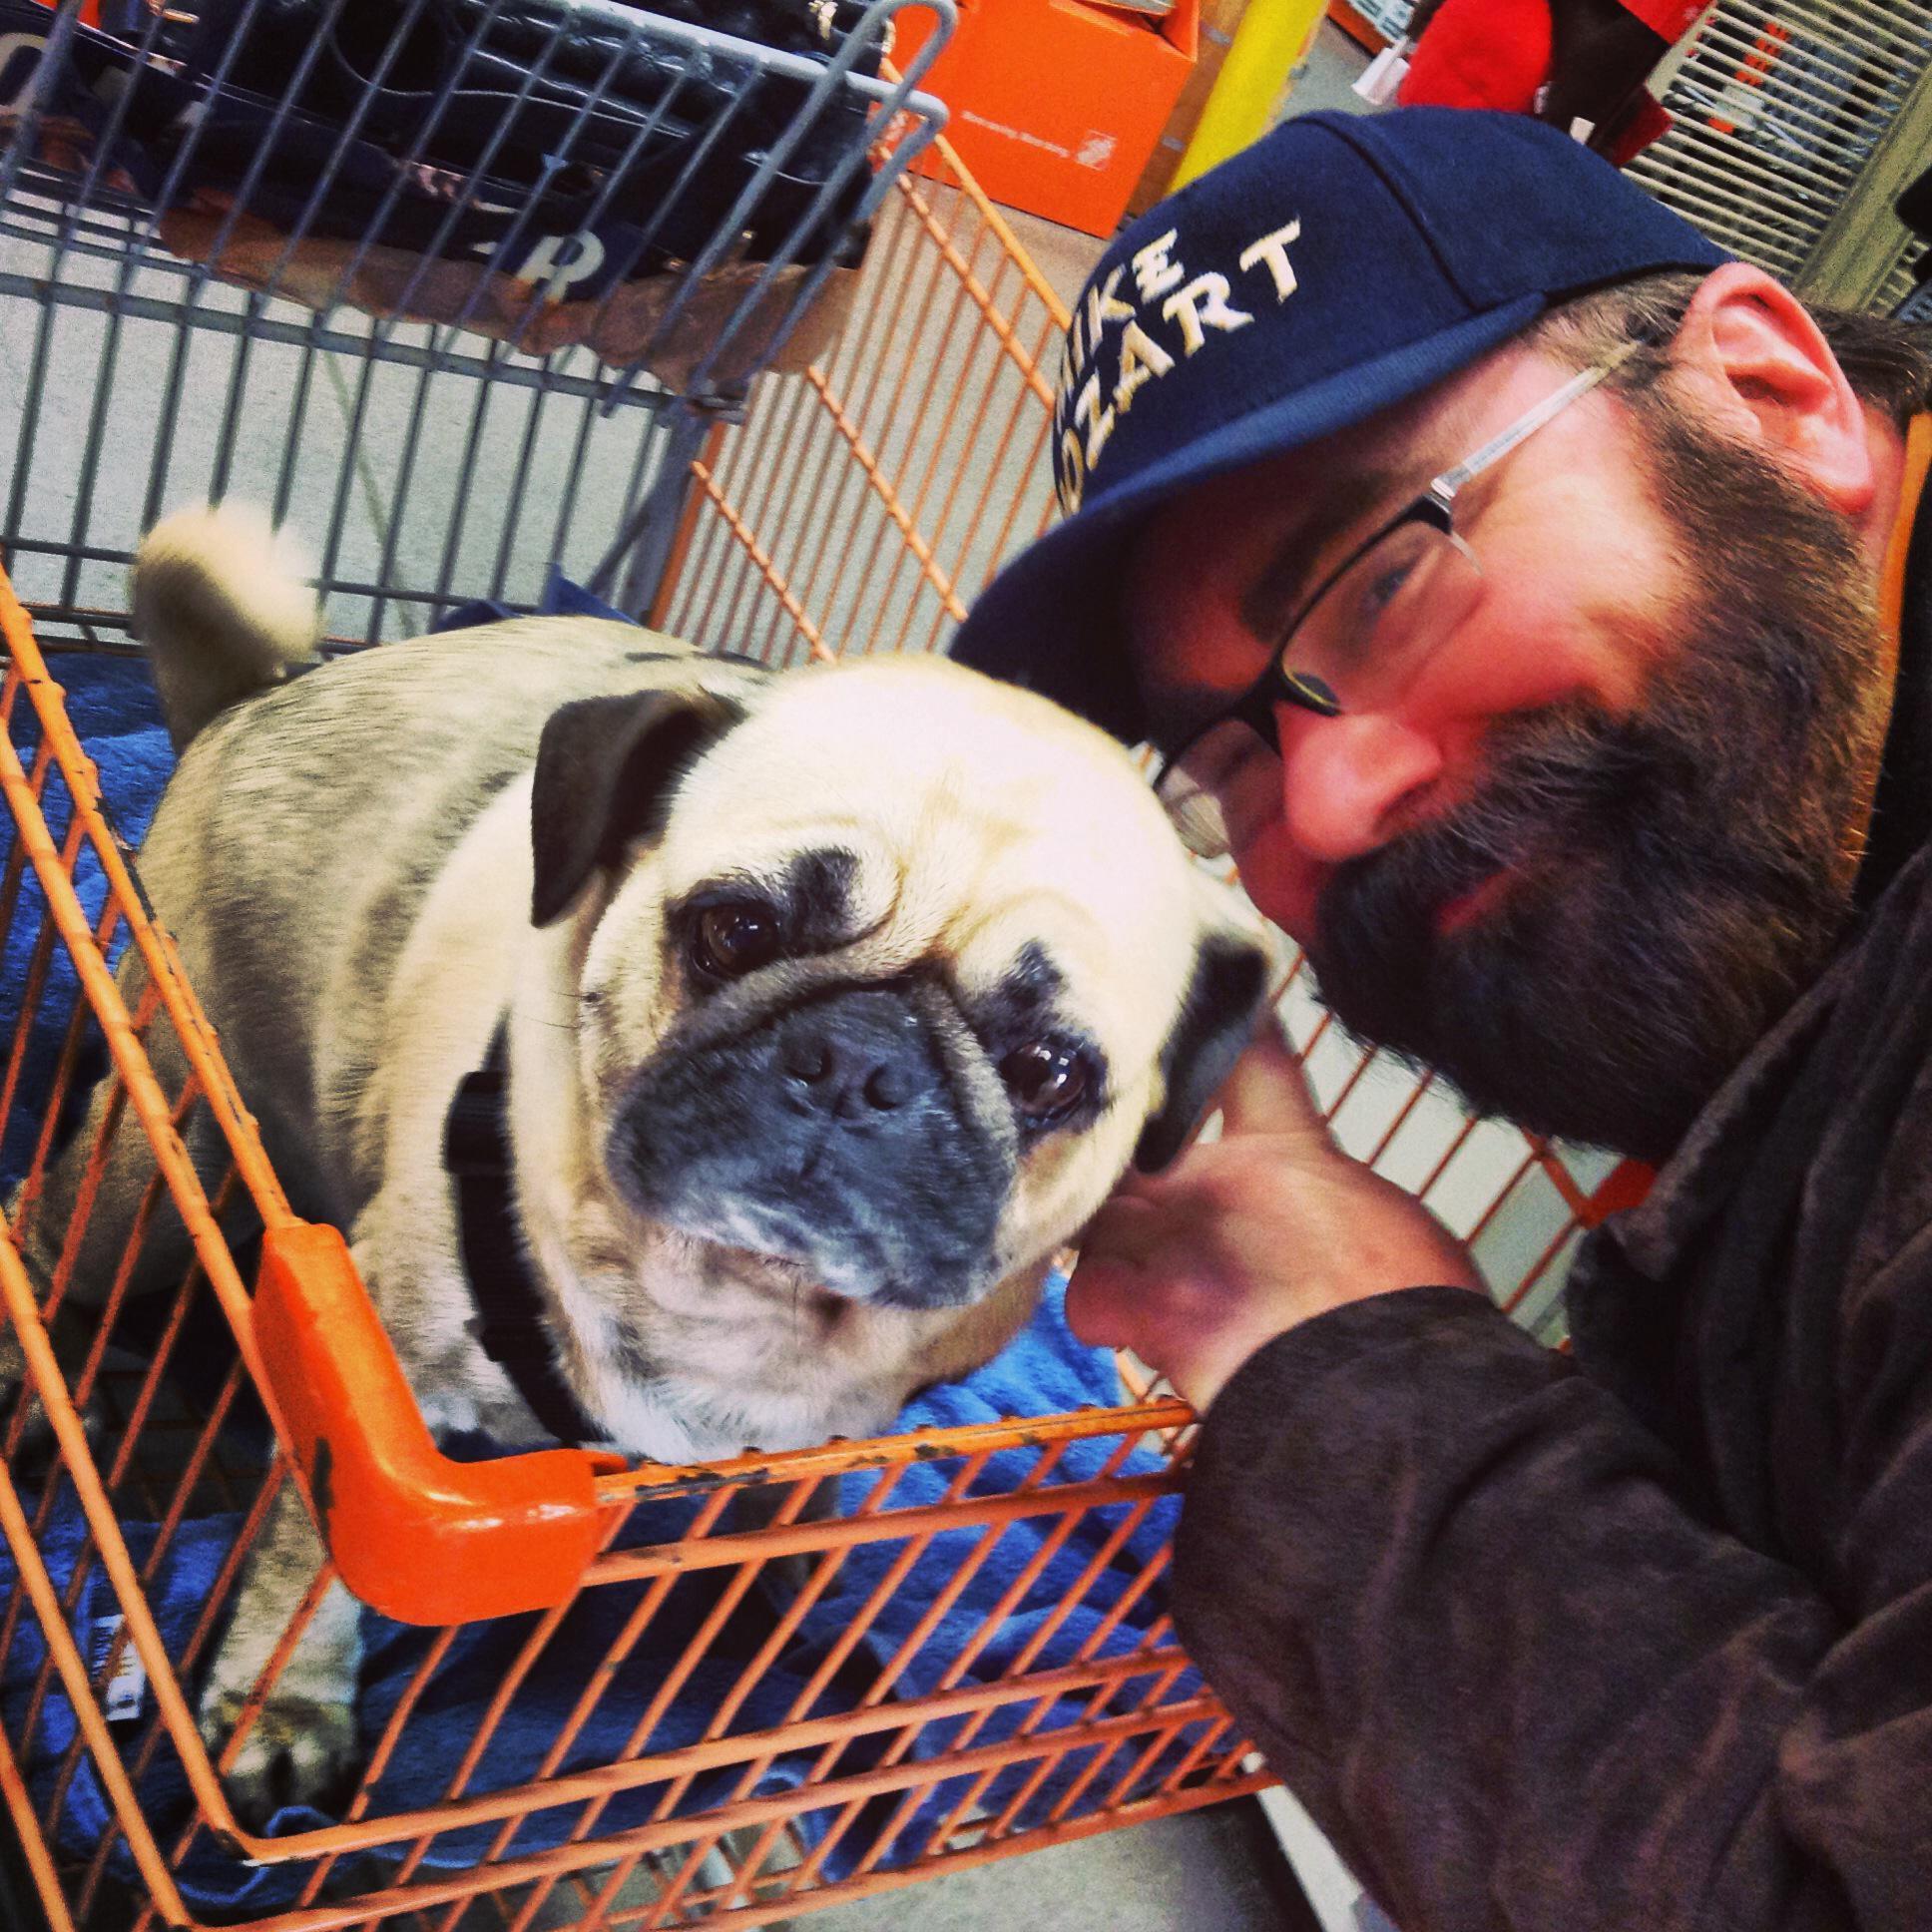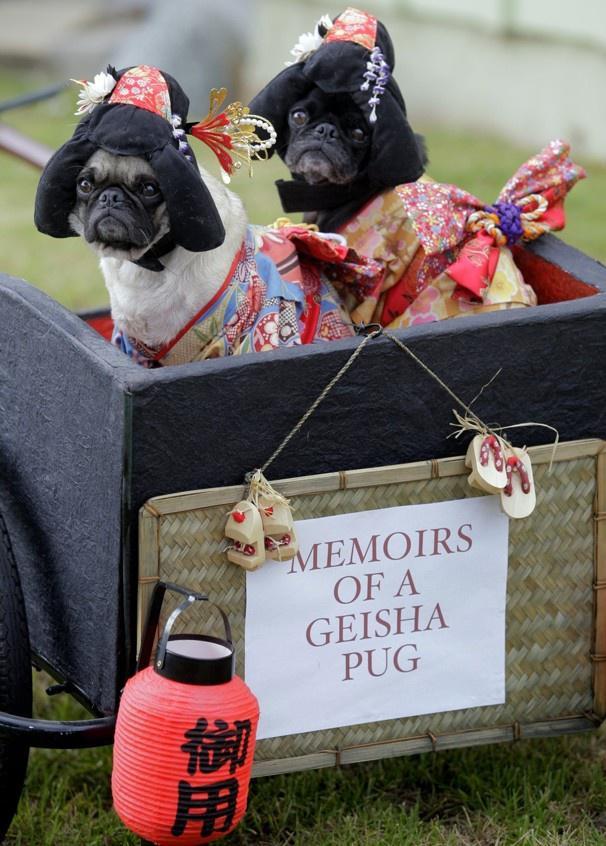The first image is the image on the left, the second image is the image on the right. For the images displayed, is the sentence "An image shows two costumed pug dogs inside a container." factually correct? Answer yes or no. Yes. The first image is the image on the left, the second image is the image on the right. For the images shown, is this caption "In one image, there are two pugs in a container that has a paper on it with printed text." true? Answer yes or no. Yes. 